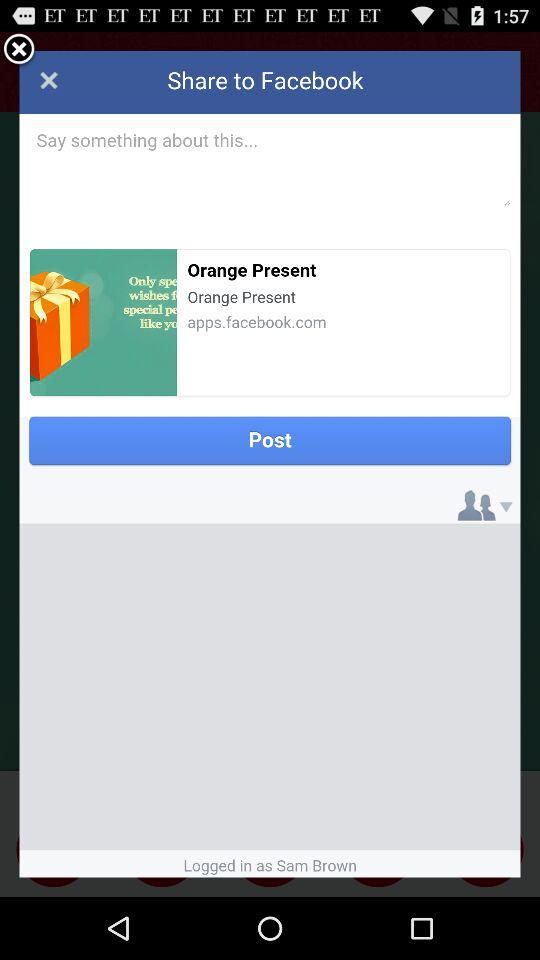What is the user name? The user name is Sam Brown. 